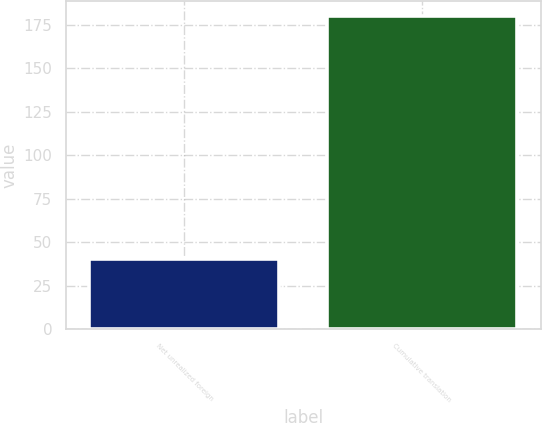Convert chart to OTSL. <chart><loc_0><loc_0><loc_500><loc_500><bar_chart><fcel>Net unrealized foreign<fcel>Cumulative translation<nl><fcel>40.4<fcel>179.7<nl></chart> 